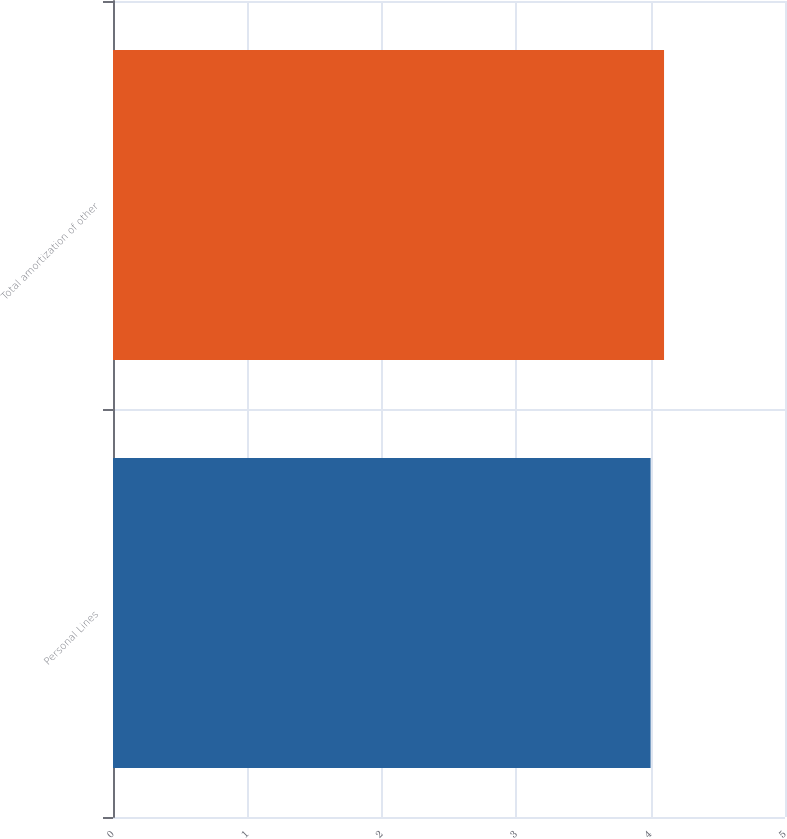<chart> <loc_0><loc_0><loc_500><loc_500><bar_chart><fcel>Personal Lines<fcel>Total amortization of other<nl><fcel>4<fcel>4.1<nl></chart> 